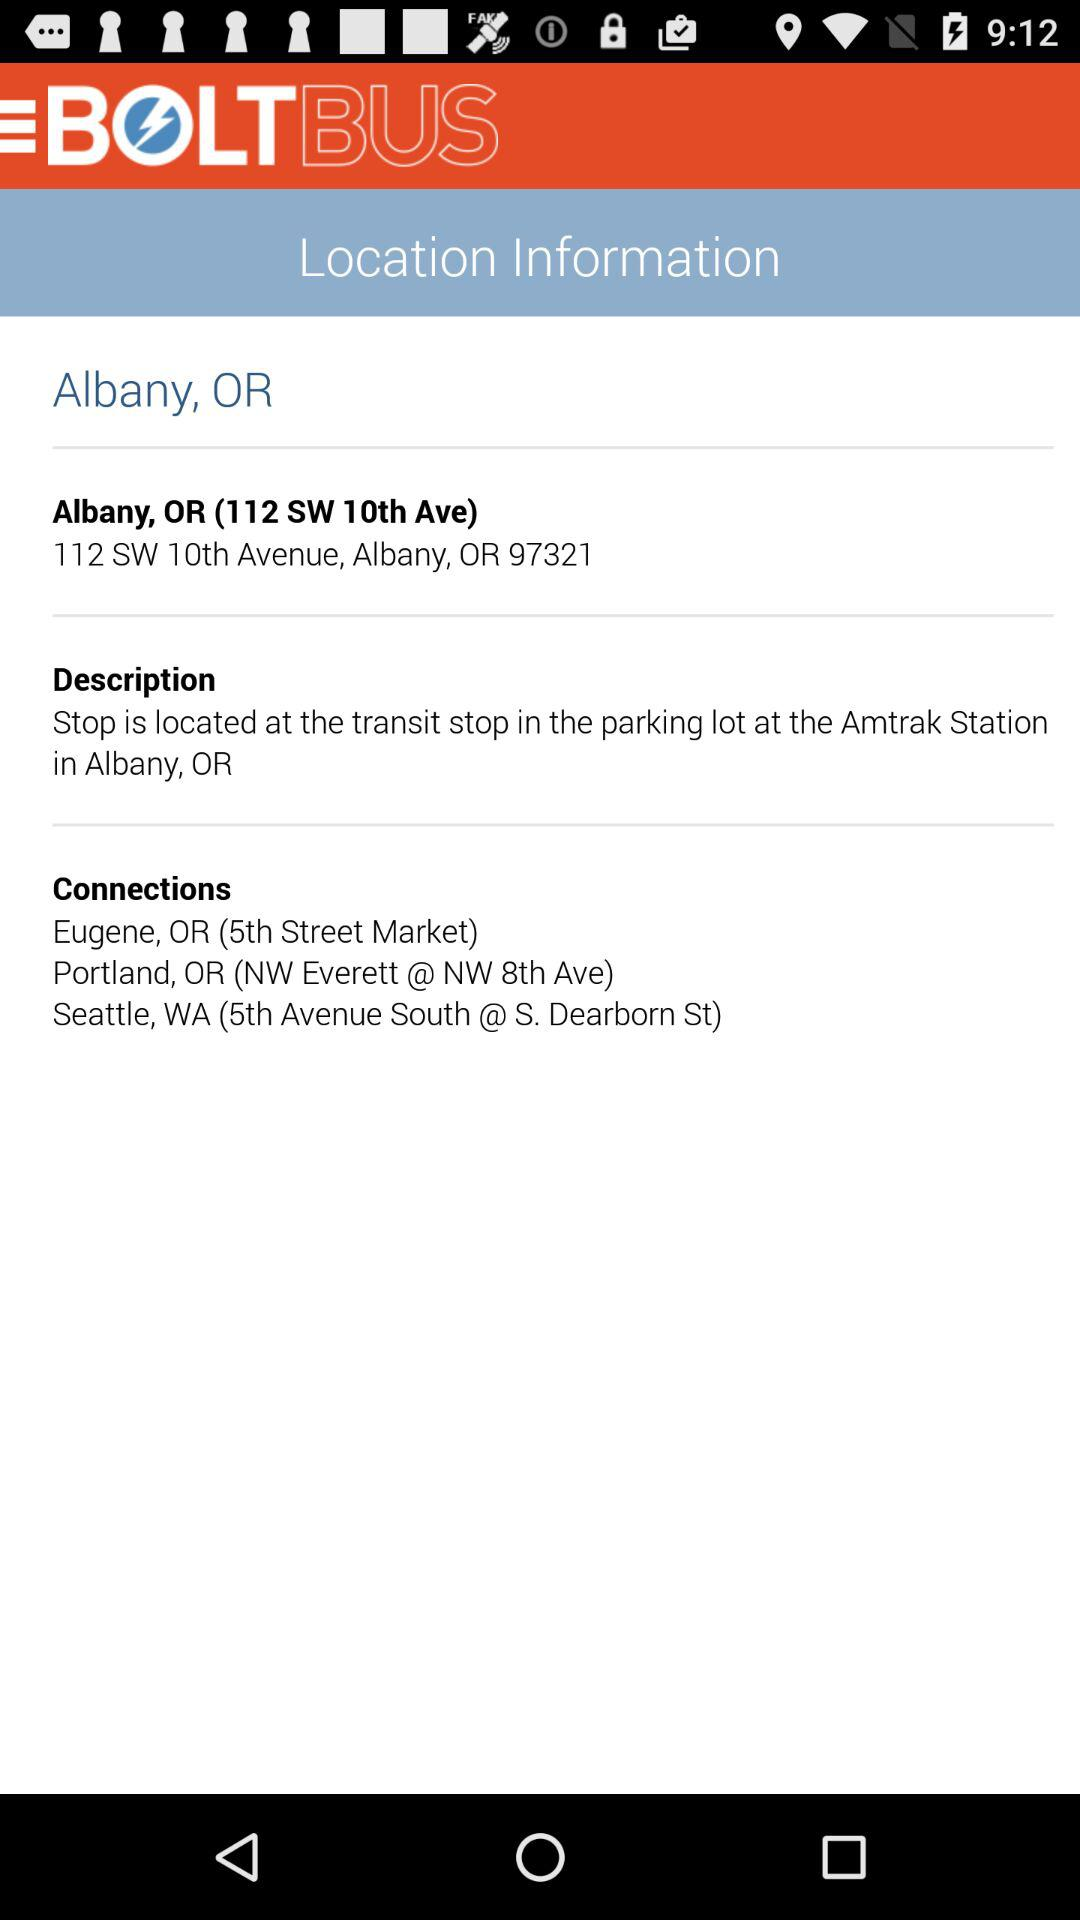What are the connection points? The connection points are "Eugene, OR (5th Street Market)", "Portland, OR (NW Everett @ NW 8th Ave)", and "Seattle, WA (5th Avenue South @ S.Dearborn St)". 